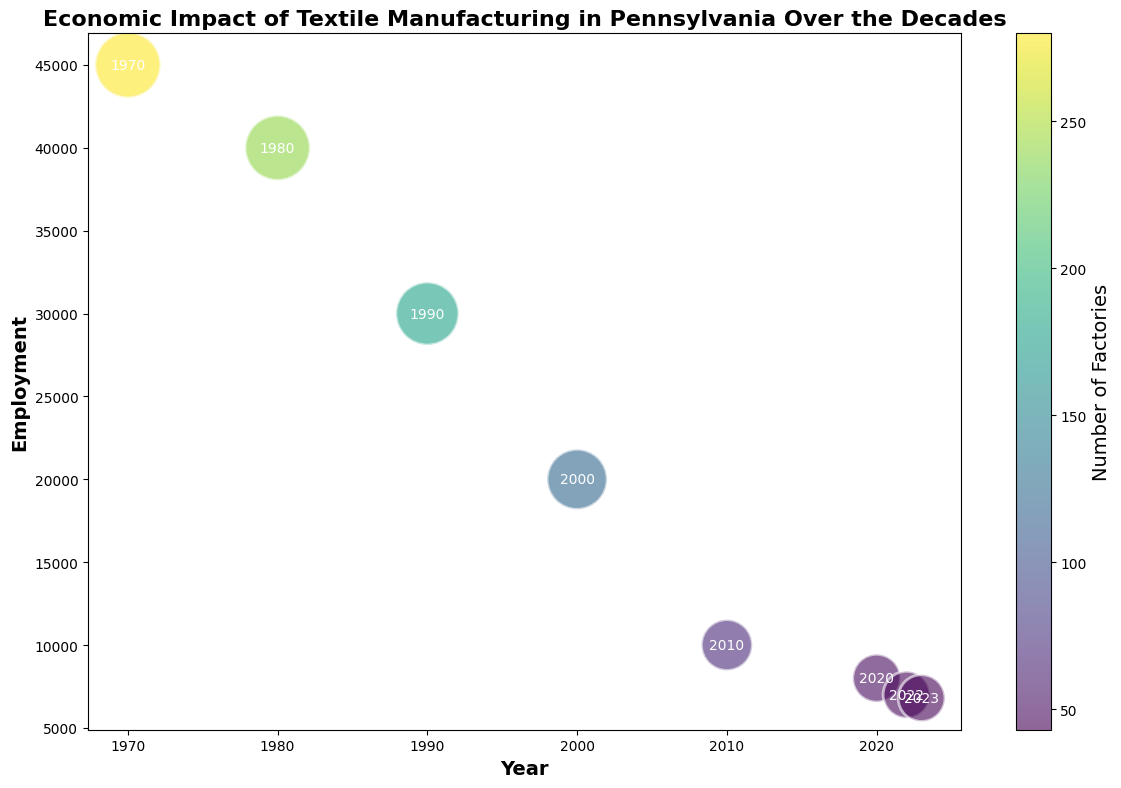What pattern do you observe in the trend of employment over time? When we look at the y-axis (Employment) across different years, we see a clear downward trend from 45,000 in 1970 to just 6,800 in 2023.
Answer: Employment has consistently decreased How does the number of factories relate to the size of bubbles in the 1990s compared to the 2020s? Smaller bubbles, representing the 2020s, correlate to lower output in millions, while larger bubbles in the 1990s indicate a higher output. Both periods, however, show a decreasing trend in the number of factories.
Answer: Bubbles are smaller in the 2020s with fewer factories and lower output Among the years plotted, which year had the highest employment? Looking at the y-axis, the highest employment value is 45,000, occurring in 1970.
Answer: 1970 What year had the smallest bubble size, and what does that signify? The smallest bubble size appears in 2023 on the plot, signifying the lowest output in millions (128).
Answer: 2023 How does the employment in 1980 compare to that in 2000? Employment in 1980 was 40,000, while in 2000 it was 20,000. Thus, employment in 1980 was double that of 2000.
Answer: 1980 had twice the employment of 2000 How did the number of factories change between 1970 and 2023? In 1970, there were 280 factories, while in 2023, there were only 43. This indicates a significant decrease of 237 factories over the period.
Answer: Decreased by 237 What can be inferred from the color of the bubbles over time? The color of the bubbles, changing from darker (many factories) in the 1970s and 1980s to lighter (fewer factories) in the 2000s and 2020s, visually represents the decline in the number of factories over time.
Answer: The number of factories decreased over time What does the annotation within each bubble represent? Each bubble has a year annotated within it, signifying the respective year for that data point.
Answer: The year associated with the data point Compare the employment trends between the years 1980 and 2010. Employment dropped from 40,000 in 1980 to 10,000 in 2010. This shows a significant reduction in employment over those 30 years.
Answer: Employment dropped by 30,000 What is the output in millions for 1990 and how does it compare to the year 2000? The output in millions for 1990 was 420, while it dropped to 350 in the year 2000, indicating a decrease of 70 million.
Answer: Decreased by 70 million 